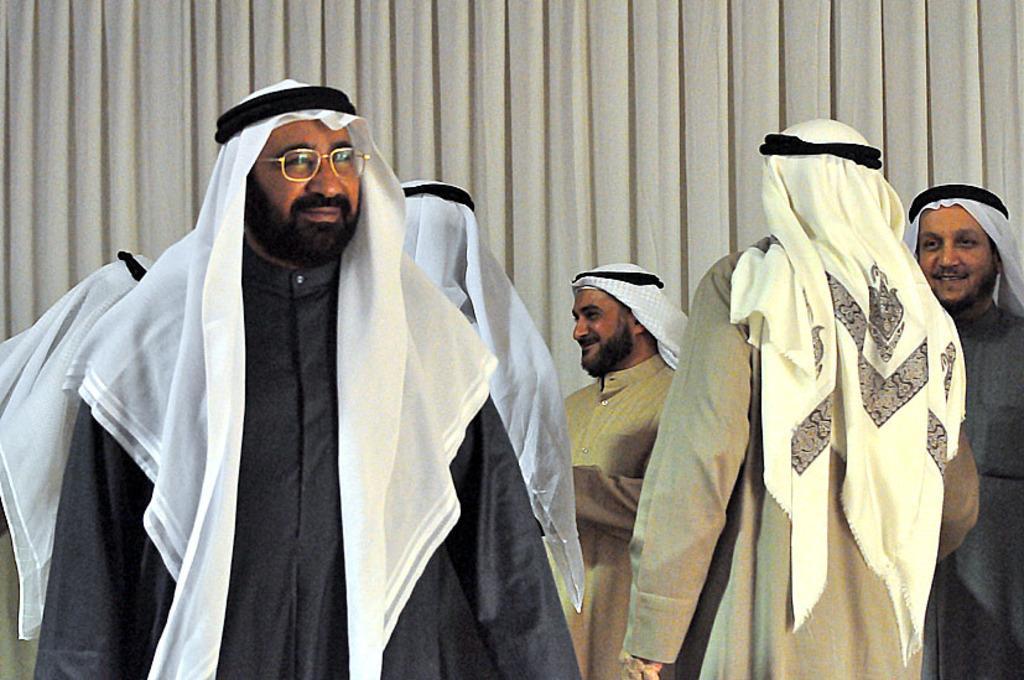How would you summarize this image in a sentence or two? In this picture there are group of people standing and smiling. At the back there is a cream color curtain. 